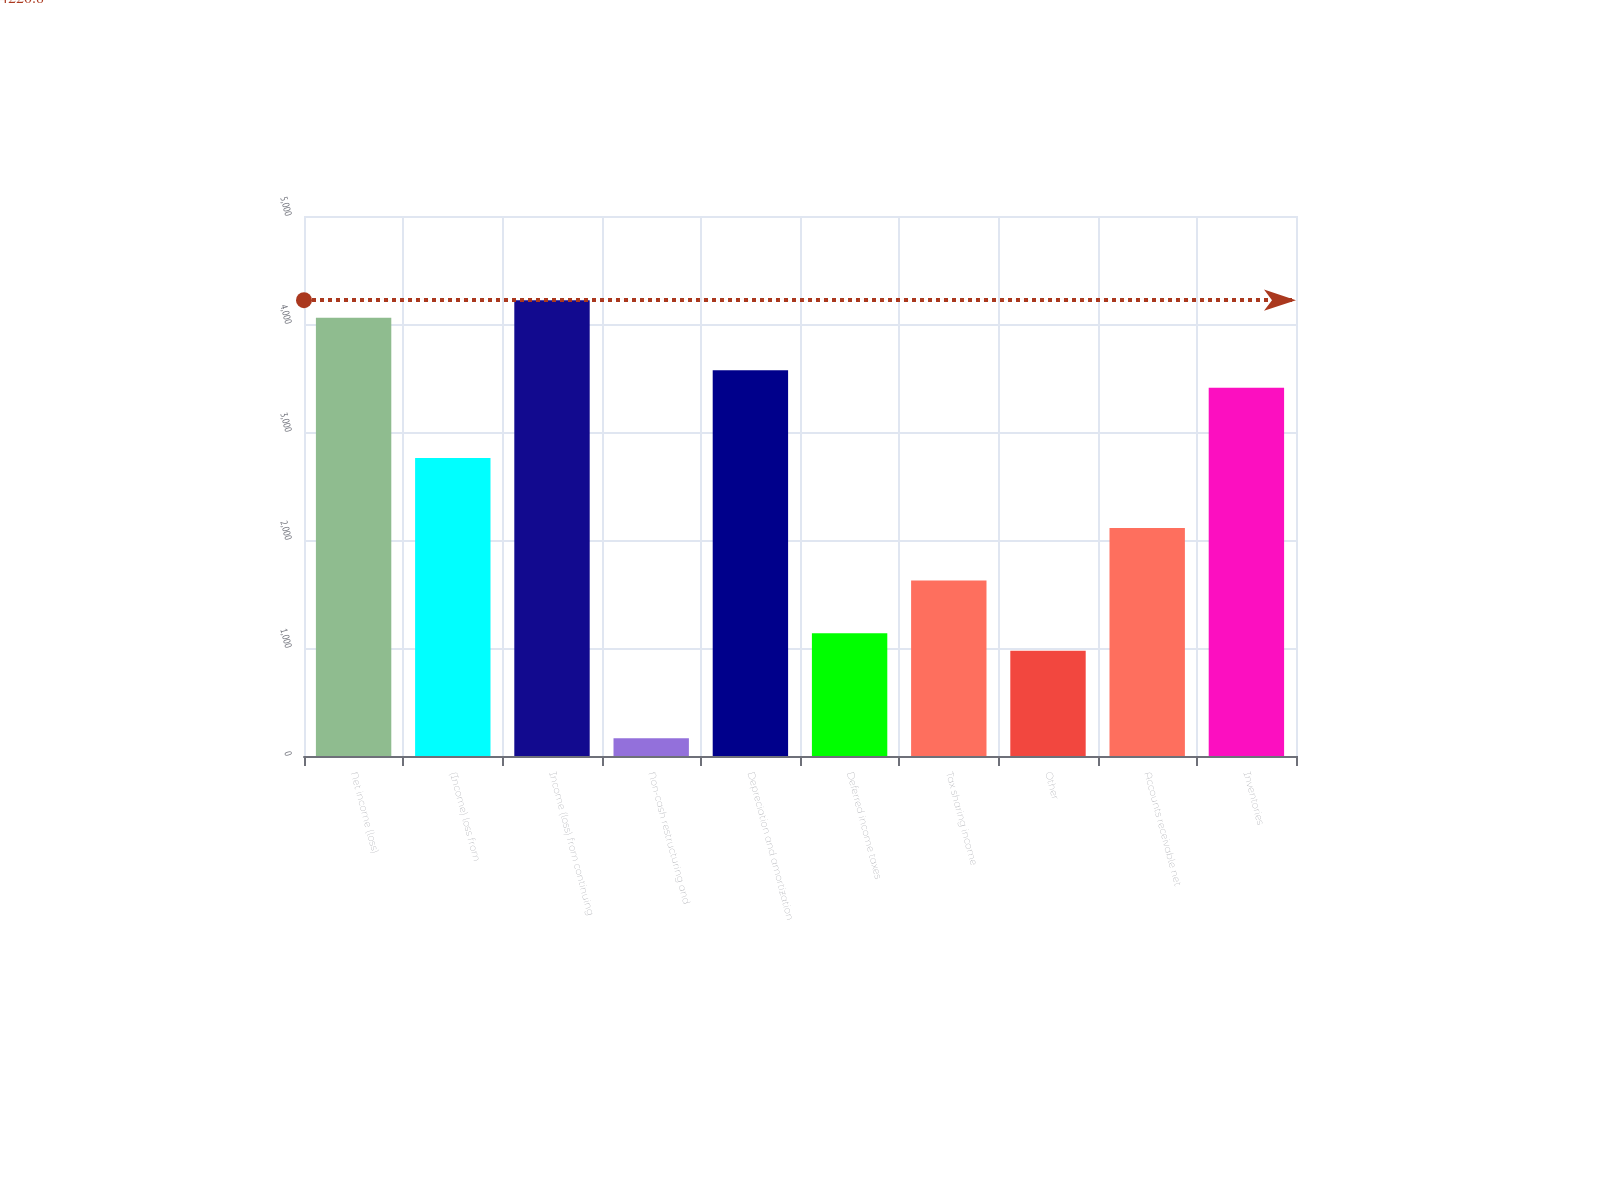<chart> <loc_0><loc_0><loc_500><loc_500><bar_chart><fcel>Net income (loss)<fcel>(Income) loss from<fcel>Income (loss) from continuing<fcel>Non-cash restructuring and<fcel>Depreciation and amortization<fcel>Deferred income taxes<fcel>Tax sharing income<fcel>Other<fcel>Accounts receivable net<fcel>Inventories<nl><fcel>4058.5<fcel>2760.1<fcel>4220.8<fcel>163.3<fcel>3571.6<fcel>1137.1<fcel>1624<fcel>974.8<fcel>2110.9<fcel>3409.3<nl></chart> 